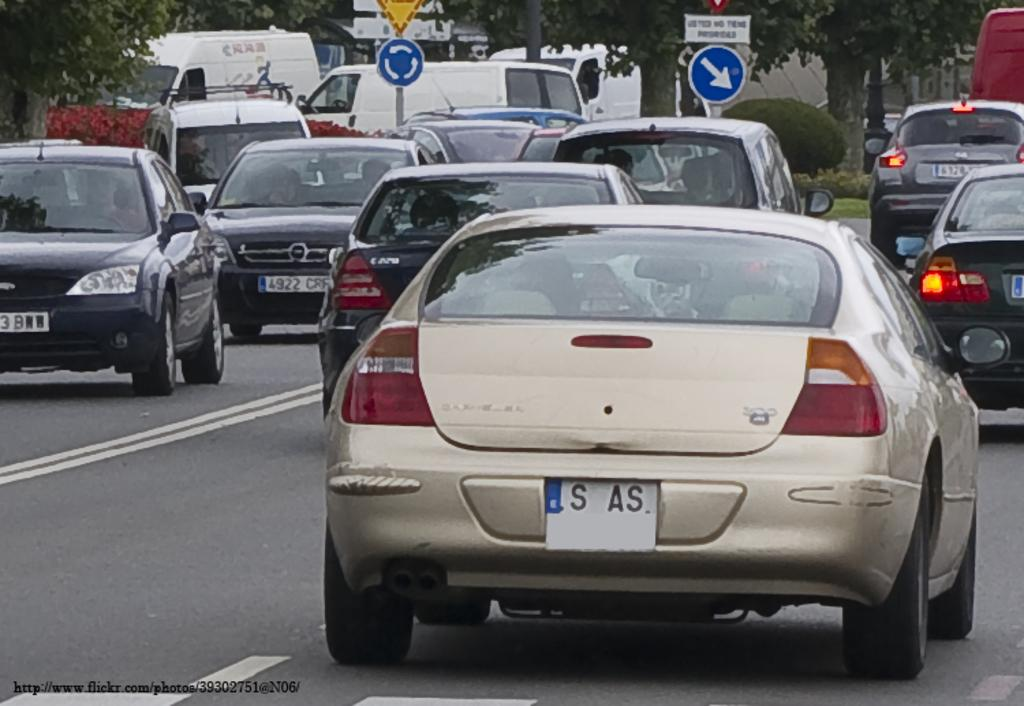What are the persons in the image doing? The persons in the image are riding vehicles on the road. What can be seen on the poles in the image? There are sign boards on poles in the image. What type of natural elements are present in the image? Trees and plants are visible in the image. Can you describe any other objects in the image? There are unspecified objects in the image. What type of mask is the sofa wearing in the image? There is no sofa or mask present in the image. How does the behavior of the persons riding vehicles affect the environment in the image? The provided facts do not mention any specific behavior of the persons riding vehicles, so it is not possible to determine how their behavior affects the environment in the image. 